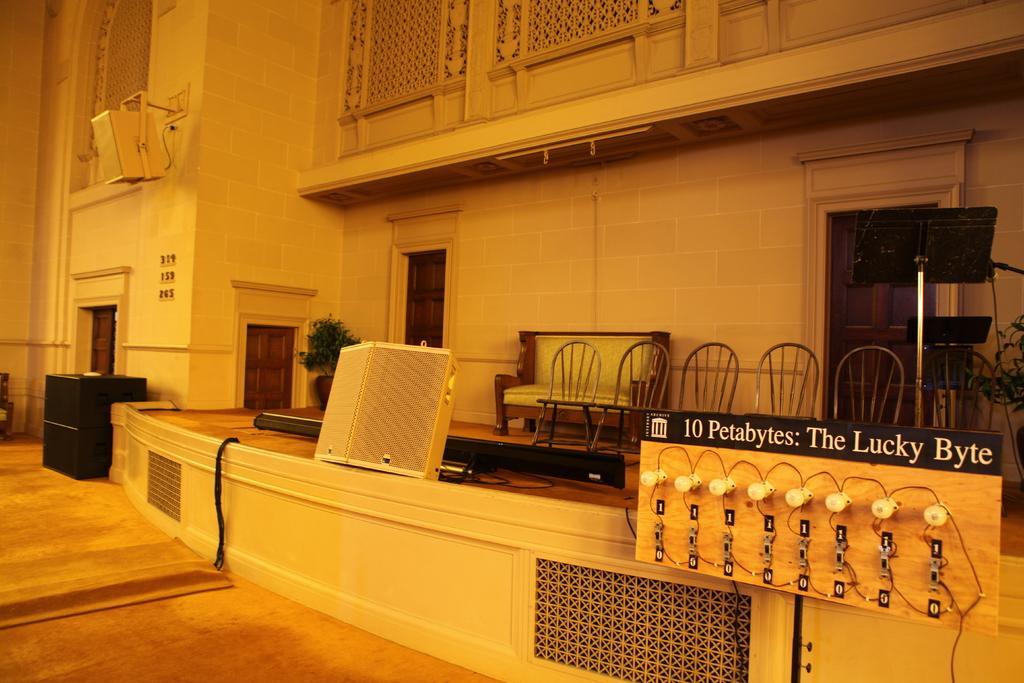Can you describe this image briefly? There are some objects in the foreground area of the image, there are doors, building structure, sofa and chairs in the background. 